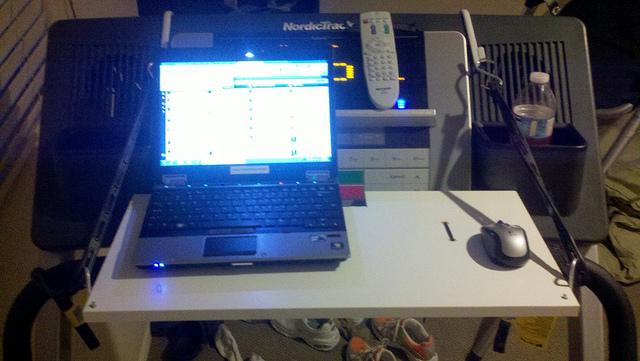What color is the liquid in the image?
Give a very brief answer. Clear. On which side of the picture is the water bottle?
Give a very brief answer. Right. Would a person be able to use this Nordictrack sitting down?
Write a very short answer. No. 